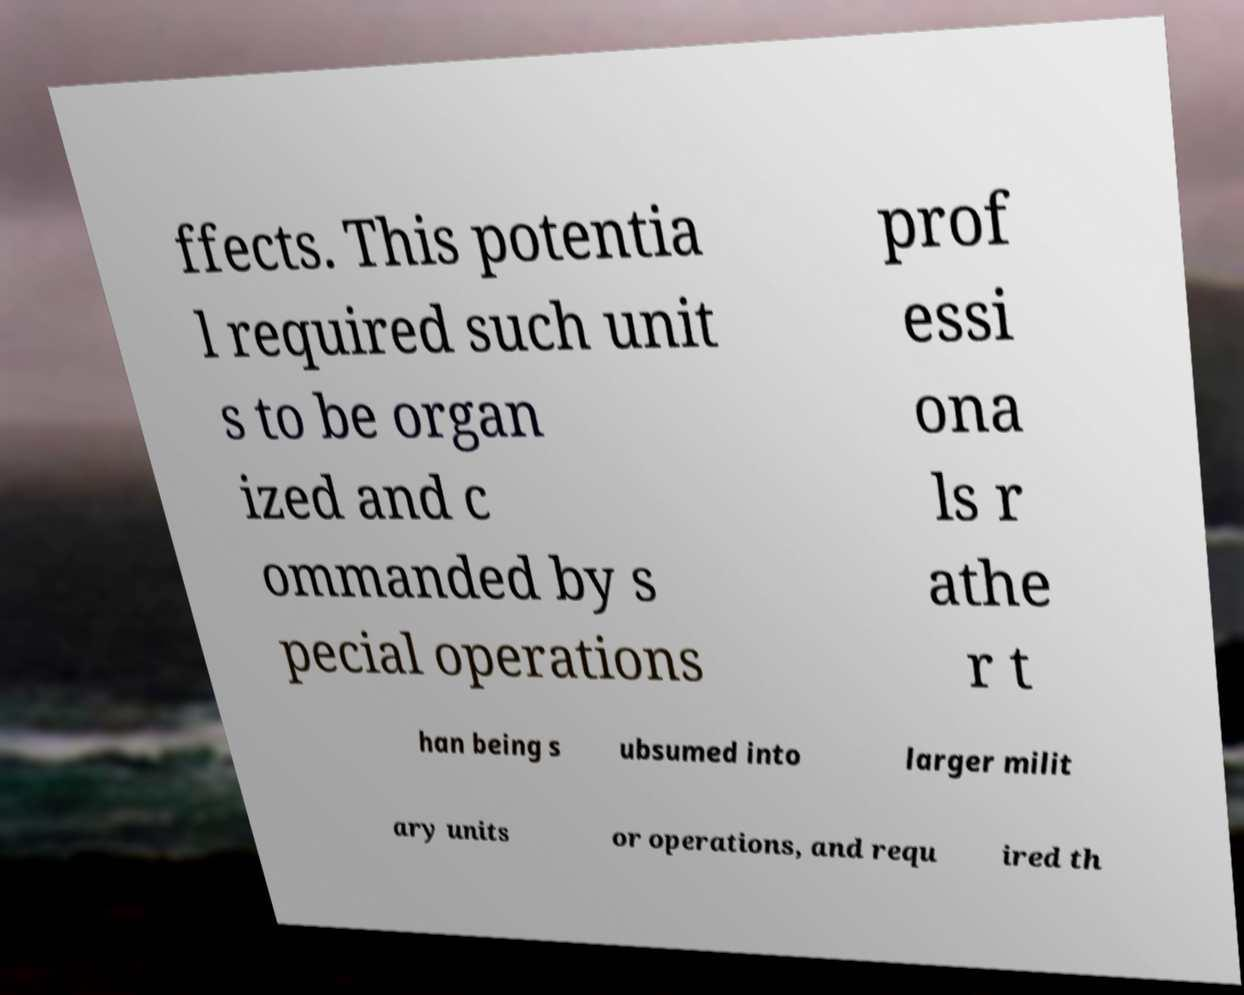I need the written content from this picture converted into text. Can you do that? ffects. This potentia l required such unit s to be organ ized and c ommanded by s pecial operations prof essi ona ls r athe r t han being s ubsumed into larger milit ary units or operations, and requ ired th 